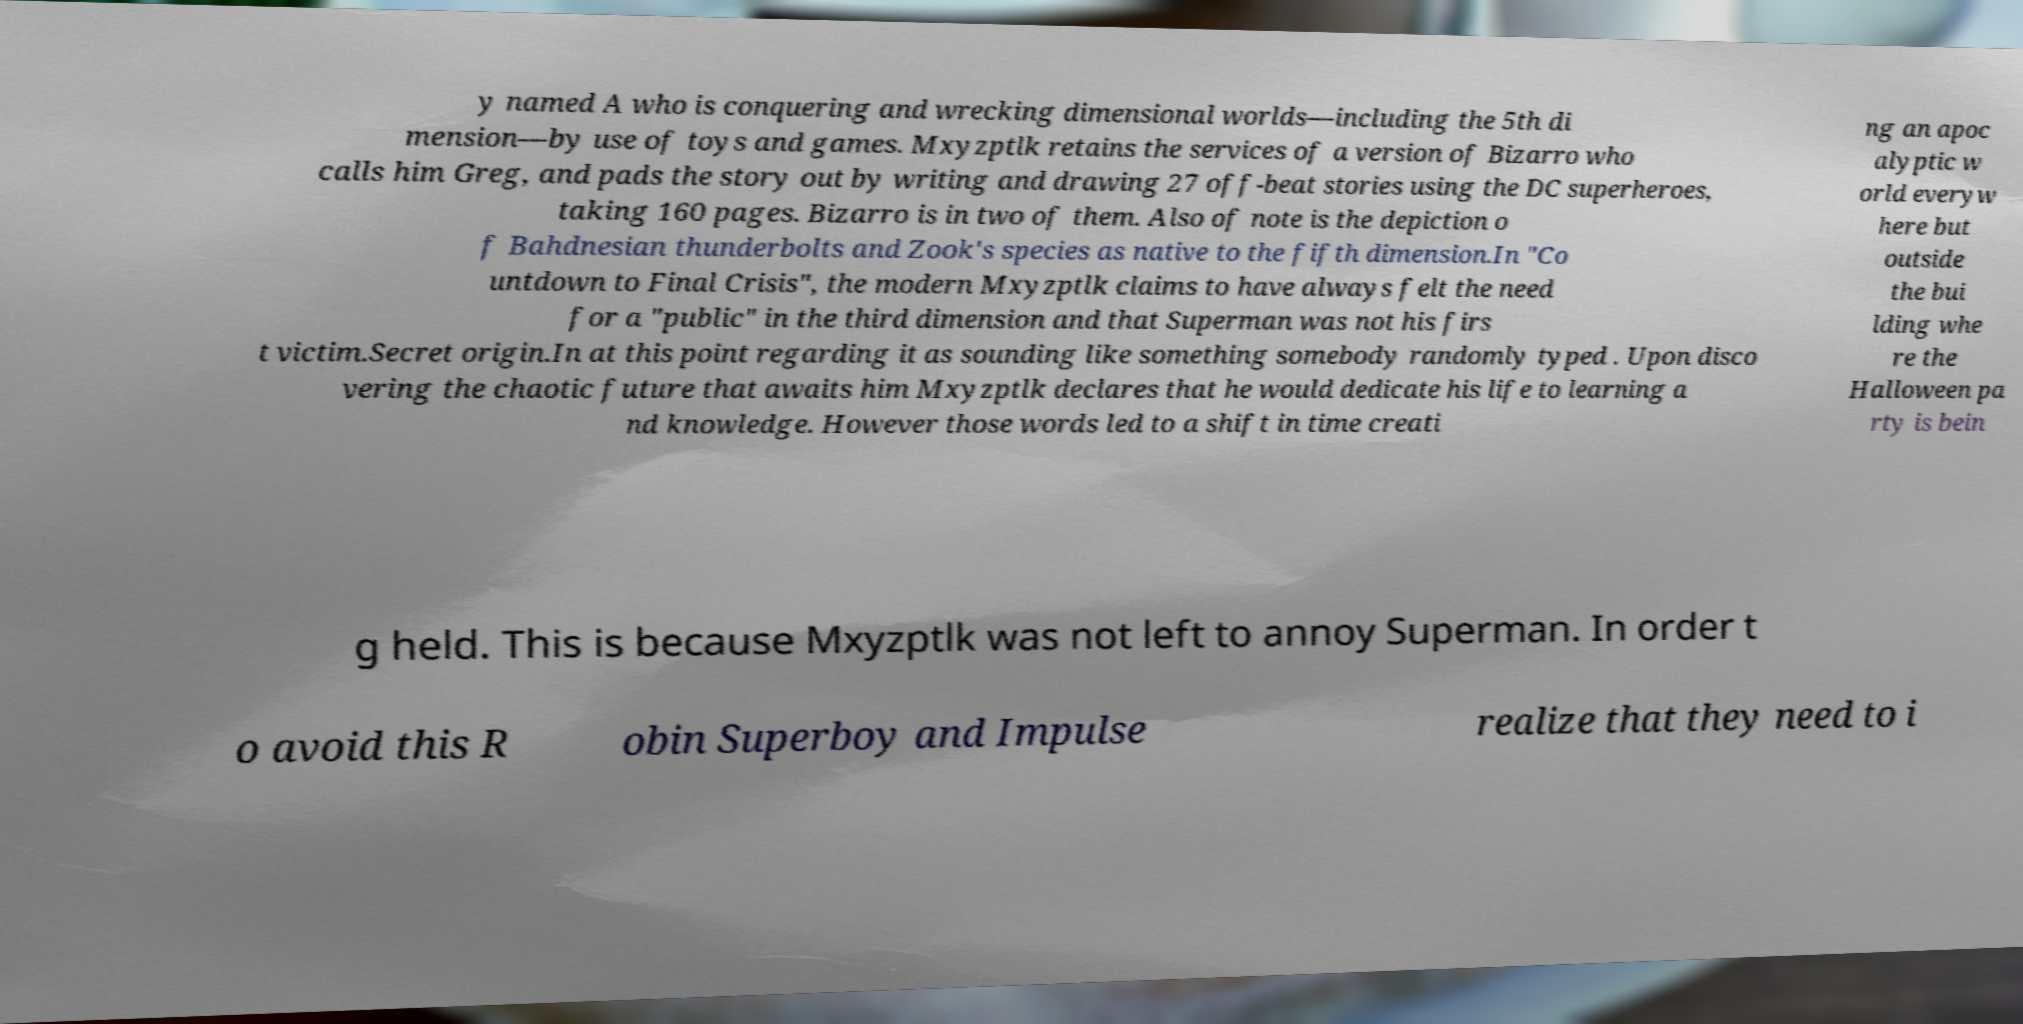There's text embedded in this image that I need extracted. Can you transcribe it verbatim? y named A who is conquering and wrecking dimensional worlds—including the 5th di mension—by use of toys and games. Mxyzptlk retains the services of a version of Bizarro who calls him Greg, and pads the story out by writing and drawing 27 off-beat stories using the DC superheroes, taking 160 pages. Bizarro is in two of them. Also of note is the depiction o f Bahdnesian thunderbolts and Zook's species as native to the fifth dimension.In "Co untdown to Final Crisis", the modern Mxyzptlk claims to have always felt the need for a "public" in the third dimension and that Superman was not his firs t victim.Secret origin.In at this point regarding it as sounding like something somebody randomly typed . Upon disco vering the chaotic future that awaits him Mxyzptlk declares that he would dedicate his life to learning a nd knowledge. However those words led to a shift in time creati ng an apoc alyptic w orld everyw here but outside the bui lding whe re the Halloween pa rty is bein g held. This is because Mxyzptlk was not left to annoy Superman. In order t o avoid this R obin Superboy and Impulse realize that they need to i 